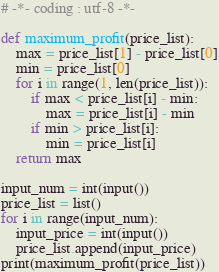<code> <loc_0><loc_0><loc_500><loc_500><_Python_># -*- coding : utf-8 -*-

def maximum_profit(price_list):
    max = price_list[1] - price_list[0]
    min = price_list[0]
    for i in range(1, len(price_list)):
        if max < price_list[i] - min:
            max = price_list[i] - min
        if min > price_list[i]:
            min = price_list[i]
    return max

input_num = int(input())
price_list = list()
for i in range(input_num):
    input_price = int(input())
    price_list.append(input_price)
print(maximum_profit(price_list))</code> 